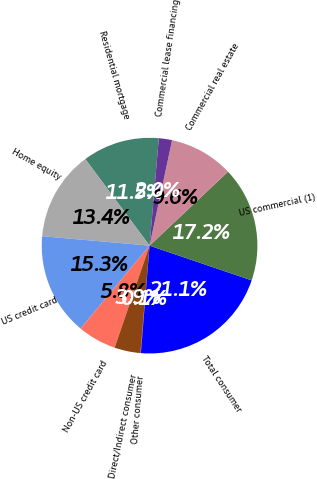<chart> <loc_0><loc_0><loc_500><loc_500><pie_chart><fcel>Residential mortgage<fcel>Home equity<fcel>US credit card<fcel>Non-US credit card<fcel>Direct/Indirect consumer<fcel>Other consumer<fcel>Total consumer<fcel>US commercial (1)<fcel>Commercial real estate<fcel>Commercial lease financing<nl><fcel>11.53%<fcel>13.44%<fcel>15.35%<fcel>5.8%<fcel>3.89%<fcel>0.07%<fcel>21.07%<fcel>17.25%<fcel>9.62%<fcel>1.98%<nl></chart> 